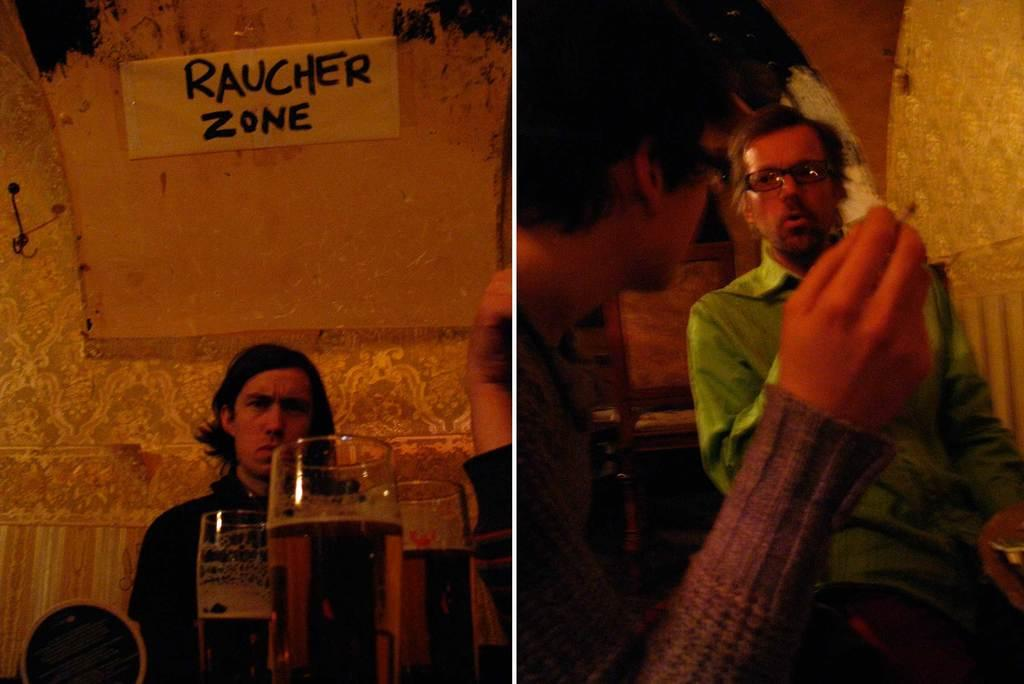Provide a one-sentence caption for the provided image. A man sits under a hand-written sign that says rauncher zone. 